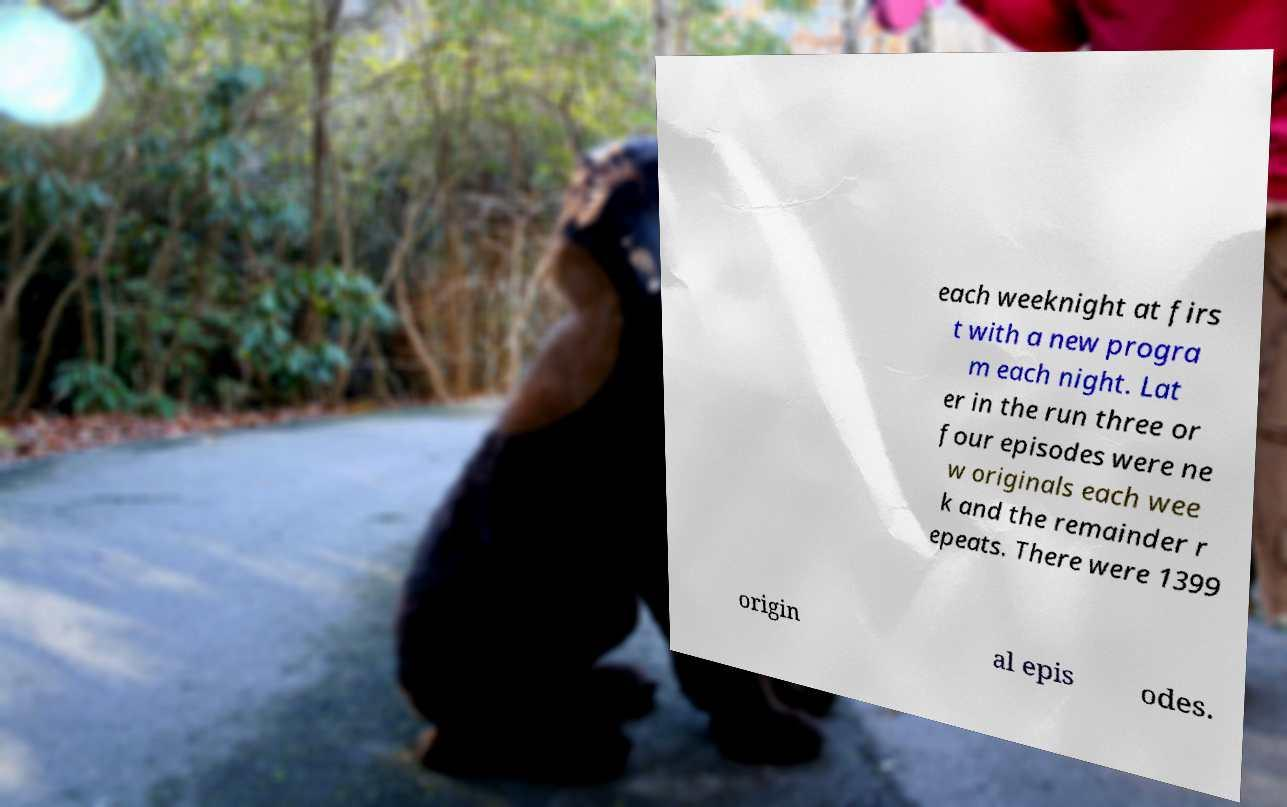Please identify and transcribe the text found in this image. each weeknight at firs t with a new progra m each night. Lat er in the run three or four episodes were ne w originals each wee k and the remainder r epeats. There were 1399 origin al epis odes. 